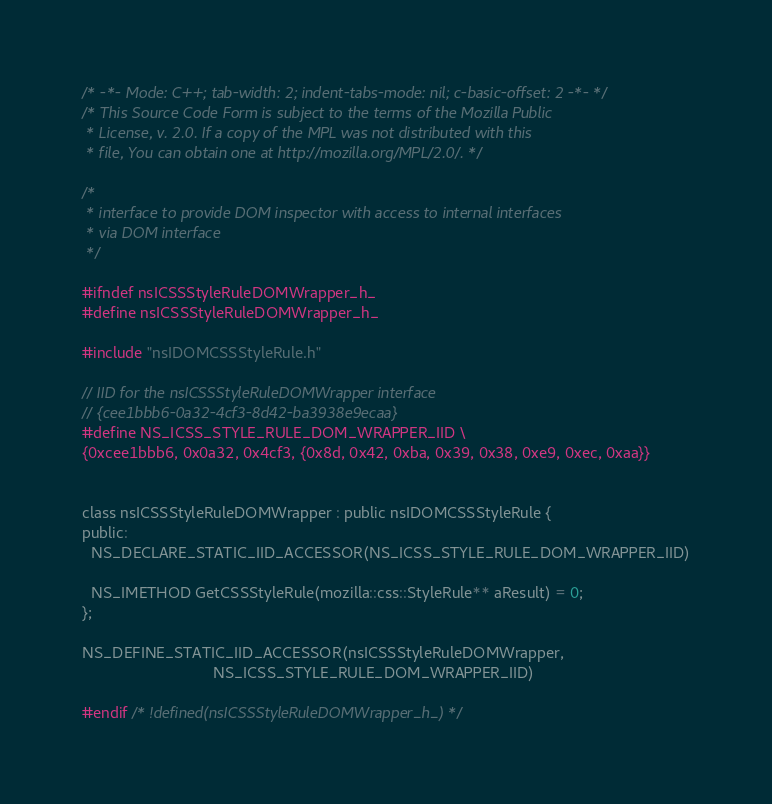<code> <loc_0><loc_0><loc_500><loc_500><_C_>/* -*- Mode: C++; tab-width: 2; indent-tabs-mode: nil; c-basic-offset: 2 -*- */
/* This Source Code Form is subject to the terms of the Mozilla Public
 * License, v. 2.0. If a copy of the MPL was not distributed with this
 * file, You can obtain one at http://mozilla.org/MPL/2.0/. */

/*
 * interface to provide DOM inspector with access to internal interfaces
 * via DOM interface
 */

#ifndef nsICSSStyleRuleDOMWrapper_h_
#define nsICSSStyleRuleDOMWrapper_h_

#include "nsIDOMCSSStyleRule.h"

// IID for the nsICSSStyleRuleDOMWrapper interface
// {cee1bbb6-0a32-4cf3-8d42-ba3938e9ecaa}
#define NS_ICSS_STYLE_RULE_DOM_WRAPPER_IID \
{0xcee1bbb6, 0x0a32, 0x4cf3, {0x8d, 0x42, 0xba, 0x39, 0x38, 0xe9, 0xec, 0xaa}}


class nsICSSStyleRuleDOMWrapper : public nsIDOMCSSStyleRule {
public:
  NS_DECLARE_STATIC_IID_ACCESSOR(NS_ICSS_STYLE_RULE_DOM_WRAPPER_IID)

  NS_IMETHOD GetCSSStyleRule(mozilla::css::StyleRule** aResult) = 0;
};

NS_DEFINE_STATIC_IID_ACCESSOR(nsICSSStyleRuleDOMWrapper,
                              NS_ICSS_STYLE_RULE_DOM_WRAPPER_IID)

#endif /* !defined(nsICSSStyleRuleDOMWrapper_h_) */
</code> 